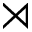<formula> <loc_0><loc_0><loc_500><loc_500>\rtimes</formula> 